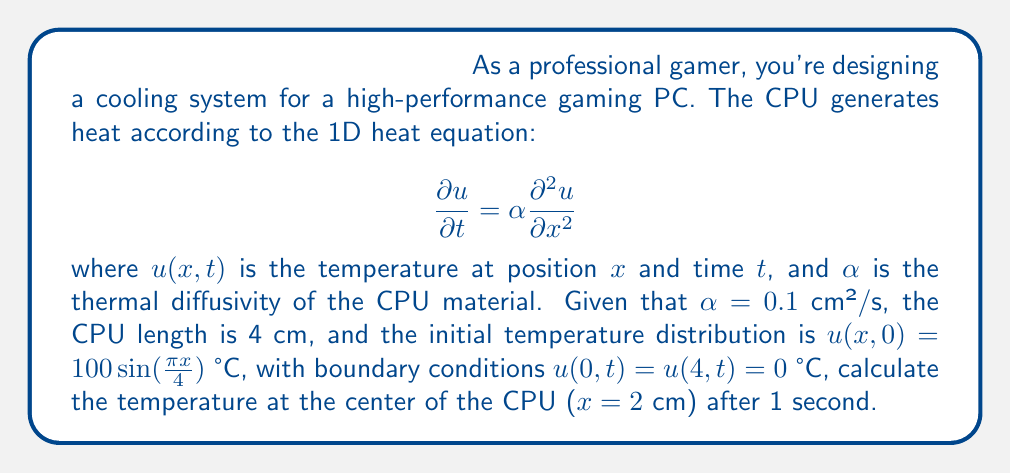Could you help me with this problem? To solve this problem, we'll use the separation of variables method for the heat equation:

1) The general solution for this problem has the form:
   $$u(x,t) = \sum_{n=1}^{\infty} B_n \sin(\frac{n\pi x}{L}) e^{-\alpha(\frac{n\pi}{L})^2 t}$$
   where $L$ is the length of the CPU (4 cm).

2) The initial condition matches the first term of this series when $n=1$:
   $$u(x,0) = 100\sin(\frac{\pi x}{4})$$

3) Therefore, $B_1 = 100$ and $B_n = 0$ for $n > 1$.

4) Our solution simplifies to:
   $$u(x,t) = 100 \sin(\frac{\pi x}{4}) e^{-\alpha(\frac{\pi}{4})^2 t}$$

5) At the center of the CPU, $x = 2$ cm. After 1 second, $t = 1$ s.

6) Substituting these values and $\alpha = 0.1$ cm²/s:
   $$u(2,1) = 100 \sin(\frac{\pi \cdot 2}{4}) e^{-0.1(\frac{\pi}{4})^2 \cdot 1}$$

7) Simplify:
   $$u(2,1) = 100 \sin(\frac{\pi}{2}) e^{-0.1(\frac{\pi}{4})^2}$$
   $$= 100 \cdot 1 \cdot e^{-0.1(\frac{\pi^2}{16})}$$
   $$\approx 80.73 \text{ °C}$$
Answer: 80.73 °C 